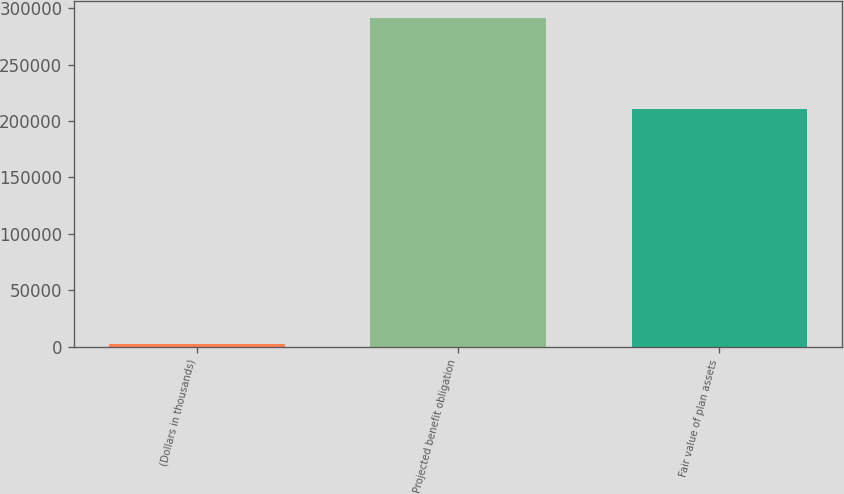Convert chart. <chart><loc_0><loc_0><loc_500><loc_500><bar_chart><fcel>(Dollars in thousands)<fcel>Projected benefit obligation<fcel>Fair value of plan assets<nl><fcel>2017<fcel>291720<fcel>210267<nl></chart> 